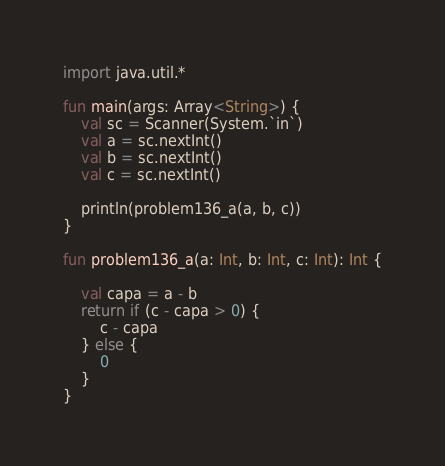Convert code to text. <code><loc_0><loc_0><loc_500><loc_500><_Kotlin_>import java.util.*

fun main(args: Array<String>) {
    val sc = Scanner(System.`in`)
    val a = sc.nextInt()
    val b = sc.nextInt()
    val c = sc.nextInt()

    println(problem136_a(a, b, c))
}

fun problem136_a(a: Int, b: Int, c: Int): Int {

    val capa = a - b
    return if (c - capa > 0) {
        c - capa
    } else {
        0
    }
}</code> 